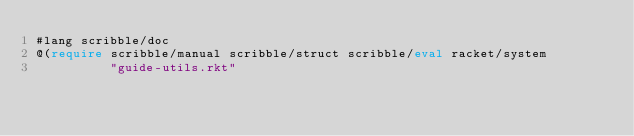Convert code to text. <code><loc_0><loc_0><loc_500><loc_500><_Racket_>#lang scribble/doc
@(require scribble/manual scribble/struct scribble/eval racket/system
          "guide-utils.rkt"</code> 